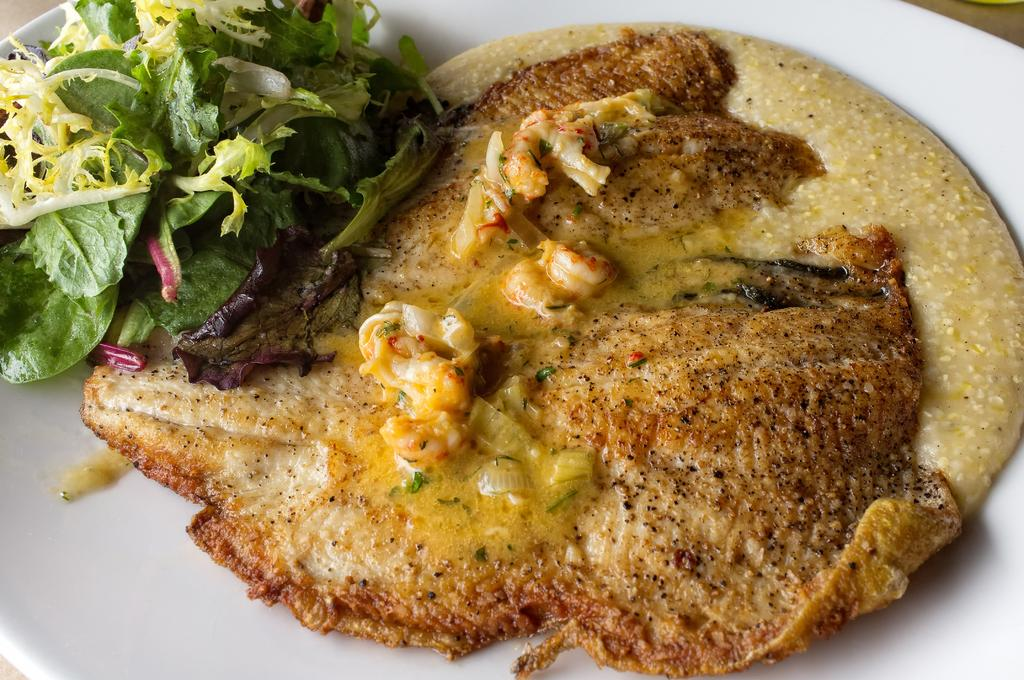What type of food contains egg in the image? The image contains food that contains egg. What other ingredients can be seen in the food? There are leafy vegetables in the food. How is the food presented in the image? The food is in a plate. Where is the plate placed in the image? The plate is placed on a surface. What type of humor can be seen in the image? There is no humor present in the image; it features food containing egg and leafy vegetables in a plate. Can you tell me how many apples are in the image? There are no apples present in the image. 